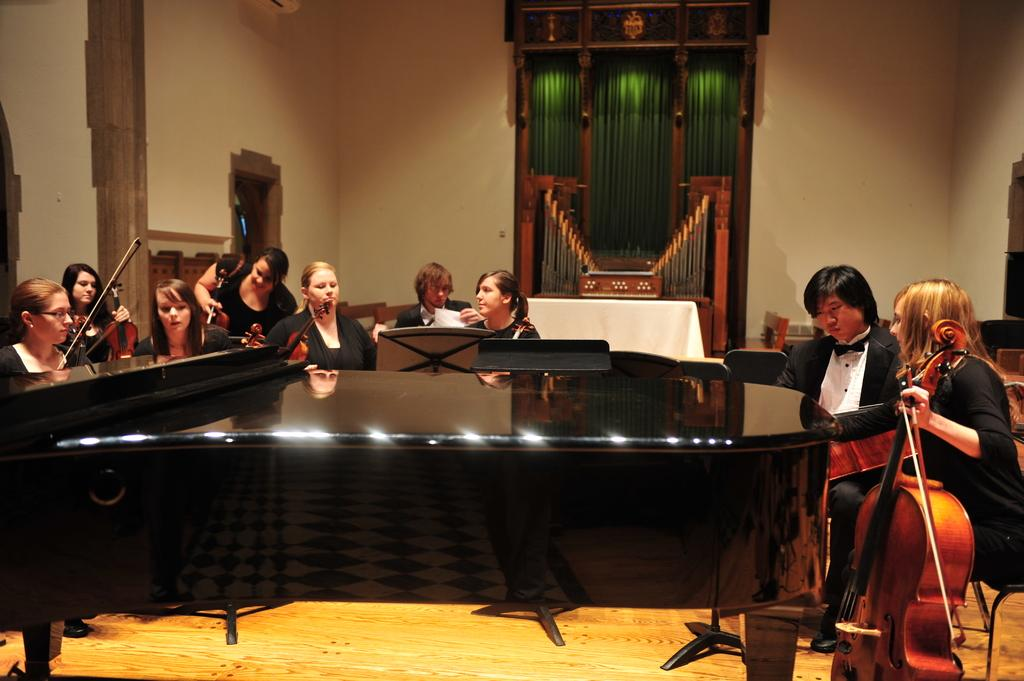What is happening in the image? There is a group of people in the image, and they are playing musical instruments. What are the people doing while playing the instruments? The people are sitting. What type of chicken is playing the drum in the image? There is no chicken or drum present in the image; the people are playing musical instruments. 